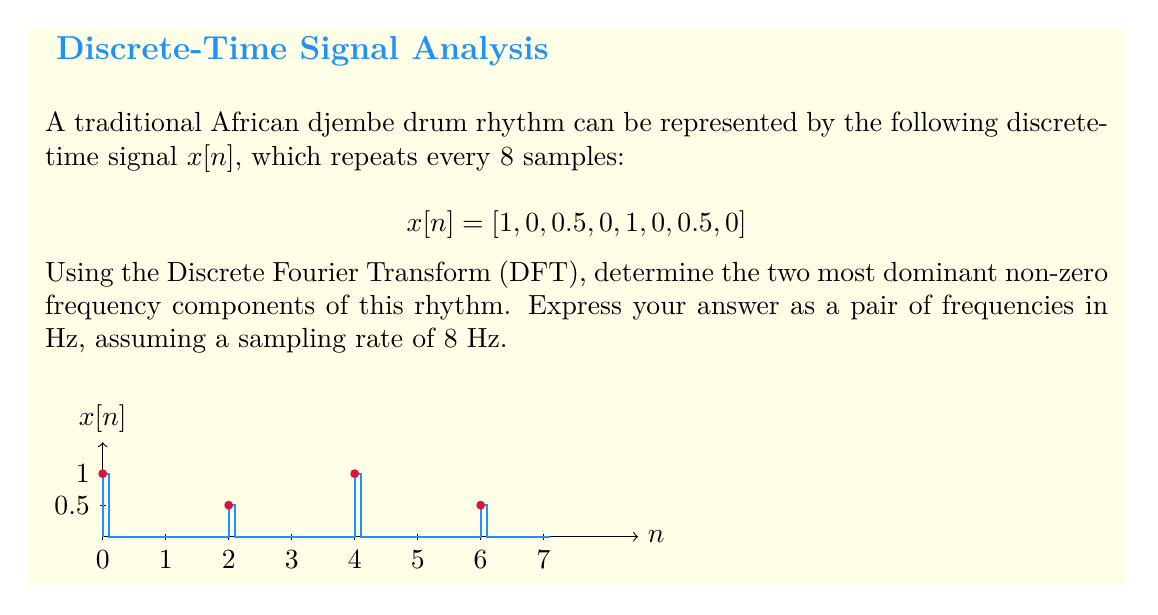Can you solve this math problem? To solve this problem, we'll follow these steps:

1) First, we need to compute the DFT of the signal $x[n]$. The DFT is given by:

   $$X[k] = \sum_{n=0}^{N-1} x[n] e^{-j2\pi kn/N}$$

   where $N = 8$ is the length of our signal.

2) We can simplify our calculations by noting that:
   
   $$X[k] = 1 + 0.5e^{-j2\pi k\cdot 2/8} + 1e^{-j2\pi k\cdot 4/8} + 0.5e^{-j2\pi k\cdot 6/8}$$

3) Calculating for $k = 0, 1, 2, 3, 4, 5, 6, 7$:

   $X[0] = 1 + 0.5 + 1 + 0.5 = 3$
   $X[1] = 1 - 0.5j - 1 + 0.5j = 0$
   $X[2] = 1 - 0.5 + 1 - 0.5 = 1$
   $X[3] = 1 + 0.5j - 1 - 0.5j = 0$
   $X[4] = 1 + 0.5 + 1 + 0.5 = 3$
   $X[5] = 1 - 0.5j - 1 + 0.5j = 0$
   $X[6] = 1 - 0.5 + 1 - 0.5 = 1$
   $X[7] = 1 + 0.5j - 1 - 0.5j = 0$

4) The magnitude of each component is:
   $|X[0]| = 3, |X[2]| = 1, |X[4]| = 3, |X[6]| = 1$, and the rest are 0.

5) The two most dominant non-zero frequency components correspond to $k = 2$ and $k = 6$.

6) To convert these to Hz, we use the formula:

   $$f = k \cdot \frac{f_s}{N}$$

   where $f_s = 8$ Hz is the sampling rate.

7) For $k = 2$: $f = 2 \cdot \frac{8}{8} = 2$ Hz
   For $k = 6$: $f = 6 \cdot \frac{8}{8} = 6$ Hz

Therefore, the two most dominant non-zero frequency components are 2 Hz and 6 Hz.
Answer: 2 Hz and 6 Hz 